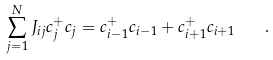Convert formula to latex. <formula><loc_0><loc_0><loc_500><loc_500>\sum _ { j = 1 } ^ { N } J _ { i j } c ^ { + } _ { j } c _ { j } = c ^ { + } _ { i - 1 } c _ { i - 1 } + c ^ { + } _ { i + 1 } c _ { i + 1 } \quad .</formula> 